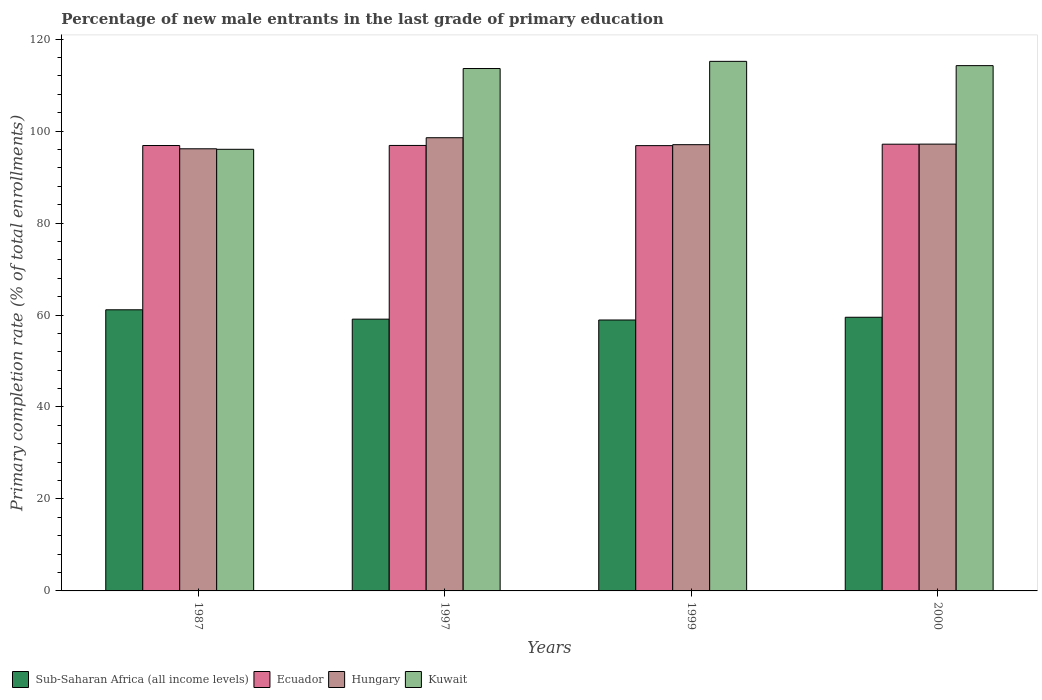How many groups of bars are there?
Your answer should be compact. 4. Are the number of bars per tick equal to the number of legend labels?
Your answer should be very brief. Yes. Are the number of bars on each tick of the X-axis equal?
Offer a very short reply. Yes. How many bars are there on the 1st tick from the left?
Offer a very short reply. 4. In how many cases, is the number of bars for a given year not equal to the number of legend labels?
Give a very brief answer. 0. What is the percentage of new male entrants in Sub-Saharan Africa (all income levels) in 1999?
Provide a short and direct response. 58.92. Across all years, what is the maximum percentage of new male entrants in Ecuador?
Give a very brief answer. 97.15. Across all years, what is the minimum percentage of new male entrants in Kuwait?
Your answer should be compact. 96.04. In which year was the percentage of new male entrants in Sub-Saharan Africa (all income levels) minimum?
Offer a very short reply. 1999. What is the total percentage of new male entrants in Ecuador in the graph?
Offer a very short reply. 387.72. What is the difference between the percentage of new male entrants in Ecuador in 1987 and that in 1997?
Your answer should be compact. -0.02. What is the difference between the percentage of new male entrants in Hungary in 1997 and the percentage of new male entrants in Kuwait in 1999?
Provide a succinct answer. -16.61. What is the average percentage of new male entrants in Sub-Saharan Africa (all income levels) per year?
Your answer should be compact. 59.67. In the year 2000, what is the difference between the percentage of new male entrants in Kuwait and percentage of new male entrants in Ecuador?
Keep it short and to the point. 17.08. What is the ratio of the percentage of new male entrants in Ecuador in 1987 to that in 2000?
Offer a terse response. 1. What is the difference between the highest and the second highest percentage of new male entrants in Kuwait?
Your response must be concise. 0.93. What is the difference between the highest and the lowest percentage of new male entrants in Sub-Saharan Africa (all income levels)?
Provide a succinct answer. 2.22. In how many years, is the percentage of new male entrants in Ecuador greater than the average percentage of new male entrants in Ecuador taken over all years?
Keep it short and to the point. 1. Is the sum of the percentage of new male entrants in Hungary in 1987 and 1997 greater than the maximum percentage of new male entrants in Kuwait across all years?
Ensure brevity in your answer.  Yes. What does the 1st bar from the left in 1999 represents?
Offer a terse response. Sub-Saharan Africa (all income levels). What does the 4th bar from the right in 1987 represents?
Your answer should be very brief. Sub-Saharan Africa (all income levels). How many bars are there?
Offer a very short reply. 16. Does the graph contain any zero values?
Keep it short and to the point. No. Where does the legend appear in the graph?
Provide a short and direct response. Bottom left. What is the title of the graph?
Ensure brevity in your answer.  Percentage of new male entrants in the last grade of primary education. Does "Faeroe Islands" appear as one of the legend labels in the graph?
Offer a very short reply. No. What is the label or title of the Y-axis?
Keep it short and to the point. Primary completion rate (% of total enrollments). What is the Primary completion rate (% of total enrollments) of Sub-Saharan Africa (all income levels) in 1987?
Provide a short and direct response. 61.14. What is the Primary completion rate (% of total enrollments) in Ecuador in 1987?
Ensure brevity in your answer.  96.86. What is the Primary completion rate (% of total enrollments) in Hungary in 1987?
Provide a short and direct response. 96.15. What is the Primary completion rate (% of total enrollments) of Kuwait in 1987?
Offer a very short reply. 96.04. What is the Primary completion rate (% of total enrollments) of Sub-Saharan Africa (all income levels) in 1997?
Your answer should be compact. 59.1. What is the Primary completion rate (% of total enrollments) in Ecuador in 1997?
Your response must be concise. 96.88. What is the Primary completion rate (% of total enrollments) of Hungary in 1997?
Make the answer very short. 98.55. What is the Primary completion rate (% of total enrollments) of Kuwait in 1997?
Ensure brevity in your answer.  113.61. What is the Primary completion rate (% of total enrollments) of Sub-Saharan Africa (all income levels) in 1999?
Make the answer very short. 58.92. What is the Primary completion rate (% of total enrollments) in Ecuador in 1999?
Give a very brief answer. 96.84. What is the Primary completion rate (% of total enrollments) in Hungary in 1999?
Offer a very short reply. 97.05. What is the Primary completion rate (% of total enrollments) of Kuwait in 1999?
Offer a very short reply. 115.16. What is the Primary completion rate (% of total enrollments) of Sub-Saharan Africa (all income levels) in 2000?
Offer a terse response. 59.52. What is the Primary completion rate (% of total enrollments) in Ecuador in 2000?
Offer a very short reply. 97.15. What is the Primary completion rate (% of total enrollments) of Hungary in 2000?
Keep it short and to the point. 97.17. What is the Primary completion rate (% of total enrollments) of Kuwait in 2000?
Provide a short and direct response. 114.23. Across all years, what is the maximum Primary completion rate (% of total enrollments) of Sub-Saharan Africa (all income levels)?
Give a very brief answer. 61.14. Across all years, what is the maximum Primary completion rate (% of total enrollments) in Ecuador?
Keep it short and to the point. 97.15. Across all years, what is the maximum Primary completion rate (% of total enrollments) of Hungary?
Make the answer very short. 98.55. Across all years, what is the maximum Primary completion rate (% of total enrollments) in Kuwait?
Provide a short and direct response. 115.16. Across all years, what is the minimum Primary completion rate (% of total enrollments) of Sub-Saharan Africa (all income levels)?
Offer a terse response. 58.92. Across all years, what is the minimum Primary completion rate (% of total enrollments) of Ecuador?
Provide a short and direct response. 96.84. Across all years, what is the minimum Primary completion rate (% of total enrollments) in Hungary?
Offer a very short reply. 96.15. Across all years, what is the minimum Primary completion rate (% of total enrollments) of Kuwait?
Ensure brevity in your answer.  96.04. What is the total Primary completion rate (% of total enrollments) of Sub-Saharan Africa (all income levels) in the graph?
Your answer should be very brief. 238.67. What is the total Primary completion rate (% of total enrollments) in Ecuador in the graph?
Your answer should be very brief. 387.72. What is the total Primary completion rate (% of total enrollments) of Hungary in the graph?
Your response must be concise. 388.92. What is the total Primary completion rate (% of total enrollments) of Kuwait in the graph?
Make the answer very short. 439.04. What is the difference between the Primary completion rate (% of total enrollments) of Sub-Saharan Africa (all income levels) in 1987 and that in 1997?
Your response must be concise. 2.04. What is the difference between the Primary completion rate (% of total enrollments) of Ecuador in 1987 and that in 1997?
Ensure brevity in your answer.  -0.02. What is the difference between the Primary completion rate (% of total enrollments) in Hungary in 1987 and that in 1997?
Provide a succinct answer. -2.4. What is the difference between the Primary completion rate (% of total enrollments) in Kuwait in 1987 and that in 1997?
Offer a very short reply. -17.57. What is the difference between the Primary completion rate (% of total enrollments) in Sub-Saharan Africa (all income levels) in 1987 and that in 1999?
Provide a short and direct response. 2.22. What is the difference between the Primary completion rate (% of total enrollments) in Ecuador in 1987 and that in 1999?
Give a very brief answer. 0.02. What is the difference between the Primary completion rate (% of total enrollments) in Hungary in 1987 and that in 1999?
Give a very brief answer. -0.9. What is the difference between the Primary completion rate (% of total enrollments) of Kuwait in 1987 and that in 1999?
Your answer should be compact. -19.13. What is the difference between the Primary completion rate (% of total enrollments) of Sub-Saharan Africa (all income levels) in 1987 and that in 2000?
Offer a very short reply. 1.62. What is the difference between the Primary completion rate (% of total enrollments) of Ecuador in 1987 and that in 2000?
Ensure brevity in your answer.  -0.29. What is the difference between the Primary completion rate (% of total enrollments) of Hungary in 1987 and that in 2000?
Give a very brief answer. -1.02. What is the difference between the Primary completion rate (% of total enrollments) in Kuwait in 1987 and that in 2000?
Ensure brevity in your answer.  -18.2. What is the difference between the Primary completion rate (% of total enrollments) of Sub-Saharan Africa (all income levels) in 1997 and that in 1999?
Keep it short and to the point. 0.18. What is the difference between the Primary completion rate (% of total enrollments) of Ecuador in 1997 and that in 1999?
Make the answer very short. 0.04. What is the difference between the Primary completion rate (% of total enrollments) of Hungary in 1997 and that in 1999?
Give a very brief answer. 1.51. What is the difference between the Primary completion rate (% of total enrollments) in Kuwait in 1997 and that in 1999?
Make the answer very short. -1.56. What is the difference between the Primary completion rate (% of total enrollments) in Sub-Saharan Africa (all income levels) in 1997 and that in 2000?
Your answer should be compact. -0.41. What is the difference between the Primary completion rate (% of total enrollments) in Ecuador in 1997 and that in 2000?
Keep it short and to the point. -0.27. What is the difference between the Primary completion rate (% of total enrollments) in Hungary in 1997 and that in 2000?
Offer a terse response. 1.39. What is the difference between the Primary completion rate (% of total enrollments) in Kuwait in 1997 and that in 2000?
Offer a terse response. -0.63. What is the difference between the Primary completion rate (% of total enrollments) in Sub-Saharan Africa (all income levels) in 1999 and that in 2000?
Make the answer very short. -0.6. What is the difference between the Primary completion rate (% of total enrollments) of Ecuador in 1999 and that in 2000?
Provide a short and direct response. -0.31. What is the difference between the Primary completion rate (% of total enrollments) of Hungary in 1999 and that in 2000?
Keep it short and to the point. -0.12. What is the difference between the Primary completion rate (% of total enrollments) of Kuwait in 1999 and that in 2000?
Keep it short and to the point. 0.93. What is the difference between the Primary completion rate (% of total enrollments) in Sub-Saharan Africa (all income levels) in 1987 and the Primary completion rate (% of total enrollments) in Ecuador in 1997?
Your answer should be very brief. -35.74. What is the difference between the Primary completion rate (% of total enrollments) in Sub-Saharan Africa (all income levels) in 1987 and the Primary completion rate (% of total enrollments) in Hungary in 1997?
Keep it short and to the point. -37.42. What is the difference between the Primary completion rate (% of total enrollments) of Sub-Saharan Africa (all income levels) in 1987 and the Primary completion rate (% of total enrollments) of Kuwait in 1997?
Provide a short and direct response. -52.47. What is the difference between the Primary completion rate (% of total enrollments) of Ecuador in 1987 and the Primary completion rate (% of total enrollments) of Hungary in 1997?
Offer a terse response. -1.7. What is the difference between the Primary completion rate (% of total enrollments) of Ecuador in 1987 and the Primary completion rate (% of total enrollments) of Kuwait in 1997?
Offer a terse response. -16.75. What is the difference between the Primary completion rate (% of total enrollments) in Hungary in 1987 and the Primary completion rate (% of total enrollments) in Kuwait in 1997?
Keep it short and to the point. -17.46. What is the difference between the Primary completion rate (% of total enrollments) of Sub-Saharan Africa (all income levels) in 1987 and the Primary completion rate (% of total enrollments) of Ecuador in 1999?
Your answer should be very brief. -35.7. What is the difference between the Primary completion rate (% of total enrollments) in Sub-Saharan Africa (all income levels) in 1987 and the Primary completion rate (% of total enrollments) in Hungary in 1999?
Offer a terse response. -35.91. What is the difference between the Primary completion rate (% of total enrollments) in Sub-Saharan Africa (all income levels) in 1987 and the Primary completion rate (% of total enrollments) in Kuwait in 1999?
Provide a short and direct response. -54.03. What is the difference between the Primary completion rate (% of total enrollments) in Ecuador in 1987 and the Primary completion rate (% of total enrollments) in Hungary in 1999?
Your answer should be compact. -0.19. What is the difference between the Primary completion rate (% of total enrollments) in Ecuador in 1987 and the Primary completion rate (% of total enrollments) in Kuwait in 1999?
Ensure brevity in your answer.  -18.31. What is the difference between the Primary completion rate (% of total enrollments) in Hungary in 1987 and the Primary completion rate (% of total enrollments) in Kuwait in 1999?
Your answer should be compact. -19.01. What is the difference between the Primary completion rate (% of total enrollments) in Sub-Saharan Africa (all income levels) in 1987 and the Primary completion rate (% of total enrollments) in Ecuador in 2000?
Your response must be concise. -36.01. What is the difference between the Primary completion rate (% of total enrollments) of Sub-Saharan Africa (all income levels) in 1987 and the Primary completion rate (% of total enrollments) of Hungary in 2000?
Keep it short and to the point. -36.03. What is the difference between the Primary completion rate (% of total enrollments) in Sub-Saharan Africa (all income levels) in 1987 and the Primary completion rate (% of total enrollments) in Kuwait in 2000?
Your answer should be very brief. -53.1. What is the difference between the Primary completion rate (% of total enrollments) of Ecuador in 1987 and the Primary completion rate (% of total enrollments) of Hungary in 2000?
Offer a very short reply. -0.31. What is the difference between the Primary completion rate (% of total enrollments) of Ecuador in 1987 and the Primary completion rate (% of total enrollments) of Kuwait in 2000?
Offer a terse response. -17.37. What is the difference between the Primary completion rate (% of total enrollments) in Hungary in 1987 and the Primary completion rate (% of total enrollments) in Kuwait in 2000?
Make the answer very short. -18.08. What is the difference between the Primary completion rate (% of total enrollments) of Sub-Saharan Africa (all income levels) in 1997 and the Primary completion rate (% of total enrollments) of Ecuador in 1999?
Your response must be concise. -37.74. What is the difference between the Primary completion rate (% of total enrollments) in Sub-Saharan Africa (all income levels) in 1997 and the Primary completion rate (% of total enrollments) in Hungary in 1999?
Ensure brevity in your answer.  -37.94. What is the difference between the Primary completion rate (% of total enrollments) in Sub-Saharan Africa (all income levels) in 1997 and the Primary completion rate (% of total enrollments) in Kuwait in 1999?
Keep it short and to the point. -56.06. What is the difference between the Primary completion rate (% of total enrollments) in Ecuador in 1997 and the Primary completion rate (% of total enrollments) in Hungary in 1999?
Provide a succinct answer. -0.17. What is the difference between the Primary completion rate (% of total enrollments) of Ecuador in 1997 and the Primary completion rate (% of total enrollments) of Kuwait in 1999?
Your response must be concise. -18.29. What is the difference between the Primary completion rate (% of total enrollments) in Hungary in 1997 and the Primary completion rate (% of total enrollments) in Kuwait in 1999?
Offer a terse response. -16.61. What is the difference between the Primary completion rate (% of total enrollments) of Sub-Saharan Africa (all income levels) in 1997 and the Primary completion rate (% of total enrollments) of Ecuador in 2000?
Offer a very short reply. -38.05. What is the difference between the Primary completion rate (% of total enrollments) in Sub-Saharan Africa (all income levels) in 1997 and the Primary completion rate (% of total enrollments) in Hungary in 2000?
Offer a very short reply. -38.07. What is the difference between the Primary completion rate (% of total enrollments) in Sub-Saharan Africa (all income levels) in 1997 and the Primary completion rate (% of total enrollments) in Kuwait in 2000?
Offer a terse response. -55.13. What is the difference between the Primary completion rate (% of total enrollments) in Ecuador in 1997 and the Primary completion rate (% of total enrollments) in Hungary in 2000?
Provide a short and direct response. -0.29. What is the difference between the Primary completion rate (% of total enrollments) of Ecuador in 1997 and the Primary completion rate (% of total enrollments) of Kuwait in 2000?
Your answer should be compact. -17.36. What is the difference between the Primary completion rate (% of total enrollments) of Hungary in 1997 and the Primary completion rate (% of total enrollments) of Kuwait in 2000?
Provide a succinct answer. -15.68. What is the difference between the Primary completion rate (% of total enrollments) in Sub-Saharan Africa (all income levels) in 1999 and the Primary completion rate (% of total enrollments) in Ecuador in 2000?
Offer a terse response. -38.23. What is the difference between the Primary completion rate (% of total enrollments) in Sub-Saharan Africa (all income levels) in 1999 and the Primary completion rate (% of total enrollments) in Hungary in 2000?
Provide a succinct answer. -38.25. What is the difference between the Primary completion rate (% of total enrollments) of Sub-Saharan Africa (all income levels) in 1999 and the Primary completion rate (% of total enrollments) of Kuwait in 2000?
Keep it short and to the point. -55.31. What is the difference between the Primary completion rate (% of total enrollments) of Ecuador in 1999 and the Primary completion rate (% of total enrollments) of Hungary in 2000?
Your response must be concise. -0.33. What is the difference between the Primary completion rate (% of total enrollments) of Ecuador in 1999 and the Primary completion rate (% of total enrollments) of Kuwait in 2000?
Provide a short and direct response. -17.4. What is the difference between the Primary completion rate (% of total enrollments) in Hungary in 1999 and the Primary completion rate (% of total enrollments) in Kuwait in 2000?
Keep it short and to the point. -17.19. What is the average Primary completion rate (% of total enrollments) in Sub-Saharan Africa (all income levels) per year?
Provide a short and direct response. 59.67. What is the average Primary completion rate (% of total enrollments) of Ecuador per year?
Your answer should be compact. 96.93. What is the average Primary completion rate (% of total enrollments) in Hungary per year?
Offer a terse response. 97.23. What is the average Primary completion rate (% of total enrollments) in Kuwait per year?
Your answer should be compact. 109.76. In the year 1987, what is the difference between the Primary completion rate (% of total enrollments) in Sub-Saharan Africa (all income levels) and Primary completion rate (% of total enrollments) in Ecuador?
Provide a short and direct response. -35.72. In the year 1987, what is the difference between the Primary completion rate (% of total enrollments) of Sub-Saharan Africa (all income levels) and Primary completion rate (% of total enrollments) of Hungary?
Offer a terse response. -35.01. In the year 1987, what is the difference between the Primary completion rate (% of total enrollments) of Sub-Saharan Africa (all income levels) and Primary completion rate (% of total enrollments) of Kuwait?
Offer a very short reply. -34.9. In the year 1987, what is the difference between the Primary completion rate (% of total enrollments) of Ecuador and Primary completion rate (% of total enrollments) of Hungary?
Offer a very short reply. 0.71. In the year 1987, what is the difference between the Primary completion rate (% of total enrollments) in Ecuador and Primary completion rate (% of total enrollments) in Kuwait?
Make the answer very short. 0.82. In the year 1987, what is the difference between the Primary completion rate (% of total enrollments) of Hungary and Primary completion rate (% of total enrollments) of Kuwait?
Your response must be concise. 0.11. In the year 1997, what is the difference between the Primary completion rate (% of total enrollments) in Sub-Saharan Africa (all income levels) and Primary completion rate (% of total enrollments) in Ecuador?
Offer a very short reply. -37.78. In the year 1997, what is the difference between the Primary completion rate (% of total enrollments) in Sub-Saharan Africa (all income levels) and Primary completion rate (% of total enrollments) in Hungary?
Your answer should be compact. -39.45. In the year 1997, what is the difference between the Primary completion rate (% of total enrollments) of Sub-Saharan Africa (all income levels) and Primary completion rate (% of total enrollments) of Kuwait?
Provide a succinct answer. -54.5. In the year 1997, what is the difference between the Primary completion rate (% of total enrollments) of Ecuador and Primary completion rate (% of total enrollments) of Hungary?
Offer a very short reply. -1.68. In the year 1997, what is the difference between the Primary completion rate (% of total enrollments) of Ecuador and Primary completion rate (% of total enrollments) of Kuwait?
Offer a very short reply. -16.73. In the year 1997, what is the difference between the Primary completion rate (% of total enrollments) in Hungary and Primary completion rate (% of total enrollments) in Kuwait?
Offer a very short reply. -15.05. In the year 1999, what is the difference between the Primary completion rate (% of total enrollments) in Sub-Saharan Africa (all income levels) and Primary completion rate (% of total enrollments) in Ecuador?
Give a very brief answer. -37.92. In the year 1999, what is the difference between the Primary completion rate (% of total enrollments) in Sub-Saharan Africa (all income levels) and Primary completion rate (% of total enrollments) in Hungary?
Offer a terse response. -38.13. In the year 1999, what is the difference between the Primary completion rate (% of total enrollments) in Sub-Saharan Africa (all income levels) and Primary completion rate (% of total enrollments) in Kuwait?
Provide a short and direct response. -56.25. In the year 1999, what is the difference between the Primary completion rate (% of total enrollments) in Ecuador and Primary completion rate (% of total enrollments) in Hungary?
Make the answer very short. -0.21. In the year 1999, what is the difference between the Primary completion rate (% of total enrollments) in Ecuador and Primary completion rate (% of total enrollments) in Kuwait?
Make the answer very short. -18.33. In the year 1999, what is the difference between the Primary completion rate (% of total enrollments) in Hungary and Primary completion rate (% of total enrollments) in Kuwait?
Provide a short and direct response. -18.12. In the year 2000, what is the difference between the Primary completion rate (% of total enrollments) in Sub-Saharan Africa (all income levels) and Primary completion rate (% of total enrollments) in Ecuador?
Offer a terse response. -37.63. In the year 2000, what is the difference between the Primary completion rate (% of total enrollments) of Sub-Saharan Africa (all income levels) and Primary completion rate (% of total enrollments) of Hungary?
Your response must be concise. -37.65. In the year 2000, what is the difference between the Primary completion rate (% of total enrollments) in Sub-Saharan Africa (all income levels) and Primary completion rate (% of total enrollments) in Kuwait?
Your answer should be compact. -54.72. In the year 2000, what is the difference between the Primary completion rate (% of total enrollments) in Ecuador and Primary completion rate (% of total enrollments) in Hungary?
Provide a succinct answer. -0.02. In the year 2000, what is the difference between the Primary completion rate (% of total enrollments) in Ecuador and Primary completion rate (% of total enrollments) in Kuwait?
Make the answer very short. -17.08. In the year 2000, what is the difference between the Primary completion rate (% of total enrollments) of Hungary and Primary completion rate (% of total enrollments) of Kuwait?
Offer a terse response. -17.07. What is the ratio of the Primary completion rate (% of total enrollments) in Sub-Saharan Africa (all income levels) in 1987 to that in 1997?
Your answer should be very brief. 1.03. What is the ratio of the Primary completion rate (% of total enrollments) in Ecuador in 1987 to that in 1997?
Keep it short and to the point. 1. What is the ratio of the Primary completion rate (% of total enrollments) in Hungary in 1987 to that in 1997?
Your response must be concise. 0.98. What is the ratio of the Primary completion rate (% of total enrollments) in Kuwait in 1987 to that in 1997?
Your response must be concise. 0.85. What is the ratio of the Primary completion rate (% of total enrollments) of Sub-Saharan Africa (all income levels) in 1987 to that in 1999?
Provide a short and direct response. 1.04. What is the ratio of the Primary completion rate (% of total enrollments) of Kuwait in 1987 to that in 1999?
Your answer should be compact. 0.83. What is the ratio of the Primary completion rate (% of total enrollments) of Sub-Saharan Africa (all income levels) in 1987 to that in 2000?
Keep it short and to the point. 1.03. What is the ratio of the Primary completion rate (% of total enrollments) in Hungary in 1987 to that in 2000?
Your answer should be very brief. 0.99. What is the ratio of the Primary completion rate (% of total enrollments) of Kuwait in 1987 to that in 2000?
Give a very brief answer. 0.84. What is the ratio of the Primary completion rate (% of total enrollments) in Hungary in 1997 to that in 1999?
Ensure brevity in your answer.  1.02. What is the ratio of the Primary completion rate (% of total enrollments) in Kuwait in 1997 to that in 1999?
Provide a succinct answer. 0.99. What is the ratio of the Primary completion rate (% of total enrollments) in Hungary in 1997 to that in 2000?
Offer a terse response. 1.01. What is the ratio of the Primary completion rate (% of total enrollments) in Sub-Saharan Africa (all income levels) in 1999 to that in 2000?
Provide a short and direct response. 0.99. What is the ratio of the Primary completion rate (% of total enrollments) of Hungary in 1999 to that in 2000?
Your answer should be very brief. 1. What is the ratio of the Primary completion rate (% of total enrollments) of Kuwait in 1999 to that in 2000?
Keep it short and to the point. 1.01. What is the difference between the highest and the second highest Primary completion rate (% of total enrollments) of Sub-Saharan Africa (all income levels)?
Ensure brevity in your answer.  1.62. What is the difference between the highest and the second highest Primary completion rate (% of total enrollments) in Ecuador?
Offer a very short reply. 0.27. What is the difference between the highest and the second highest Primary completion rate (% of total enrollments) in Hungary?
Keep it short and to the point. 1.39. What is the difference between the highest and the second highest Primary completion rate (% of total enrollments) in Kuwait?
Your answer should be compact. 0.93. What is the difference between the highest and the lowest Primary completion rate (% of total enrollments) of Sub-Saharan Africa (all income levels)?
Make the answer very short. 2.22. What is the difference between the highest and the lowest Primary completion rate (% of total enrollments) of Ecuador?
Give a very brief answer. 0.31. What is the difference between the highest and the lowest Primary completion rate (% of total enrollments) of Hungary?
Give a very brief answer. 2.4. What is the difference between the highest and the lowest Primary completion rate (% of total enrollments) of Kuwait?
Offer a terse response. 19.13. 